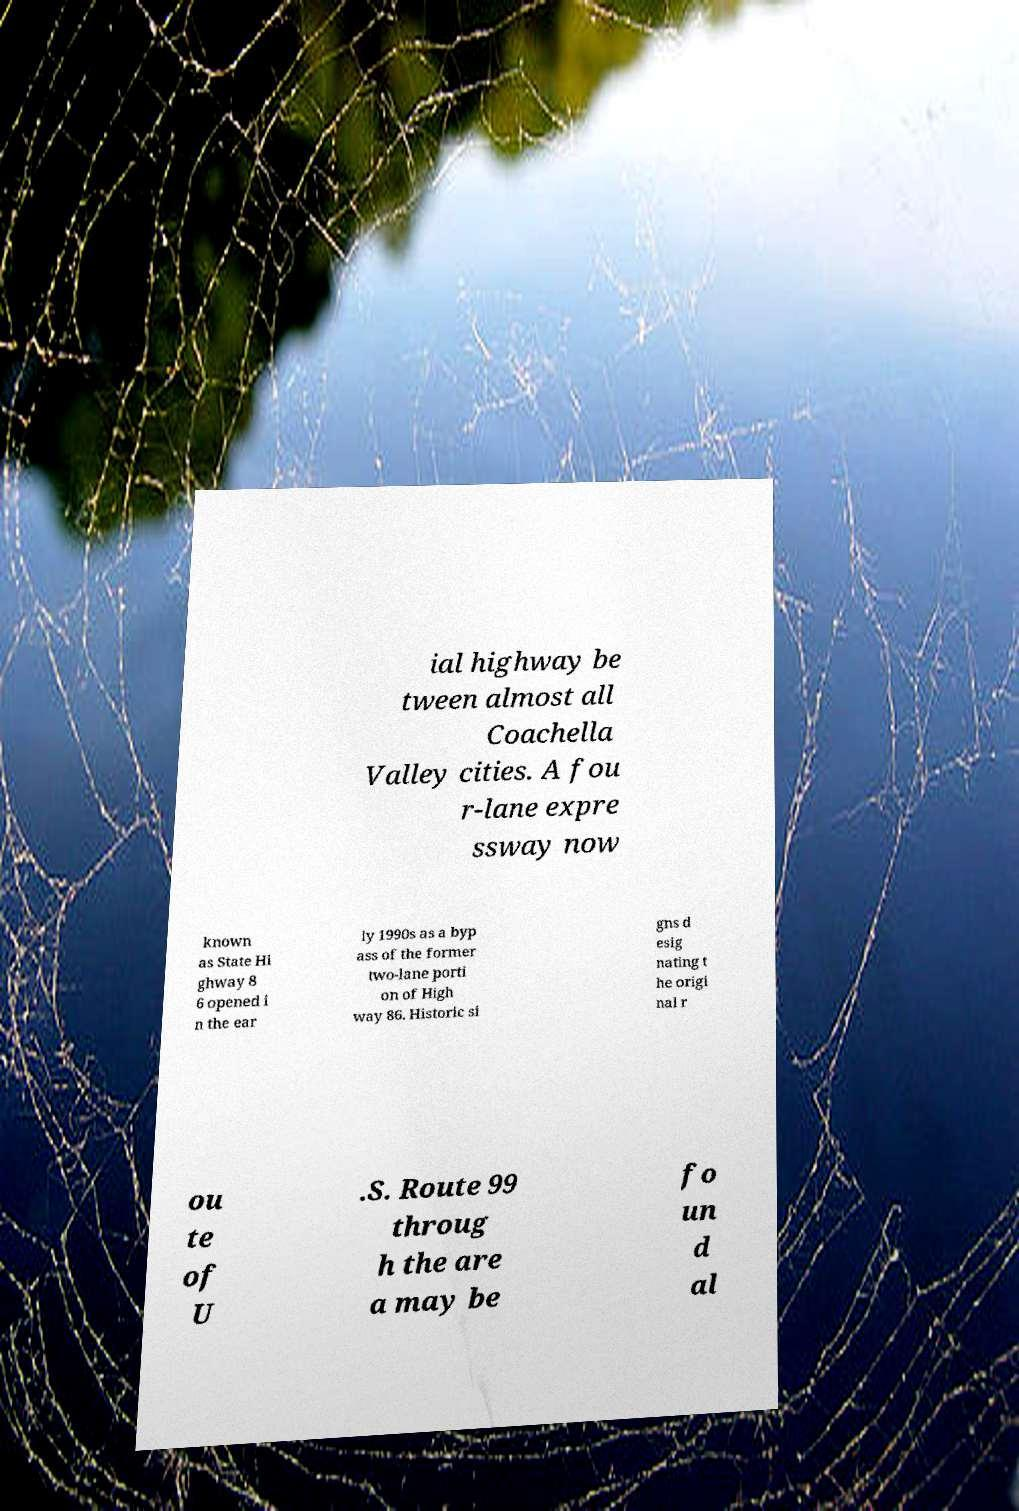Please read and relay the text visible in this image. What does it say? ial highway be tween almost all Coachella Valley cities. A fou r-lane expre ssway now known as State Hi ghway 8 6 opened i n the ear ly 1990s as a byp ass of the former two-lane porti on of High way 86. Historic si gns d esig nating t he origi nal r ou te of U .S. Route 99 throug h the are a may be fo un d al 